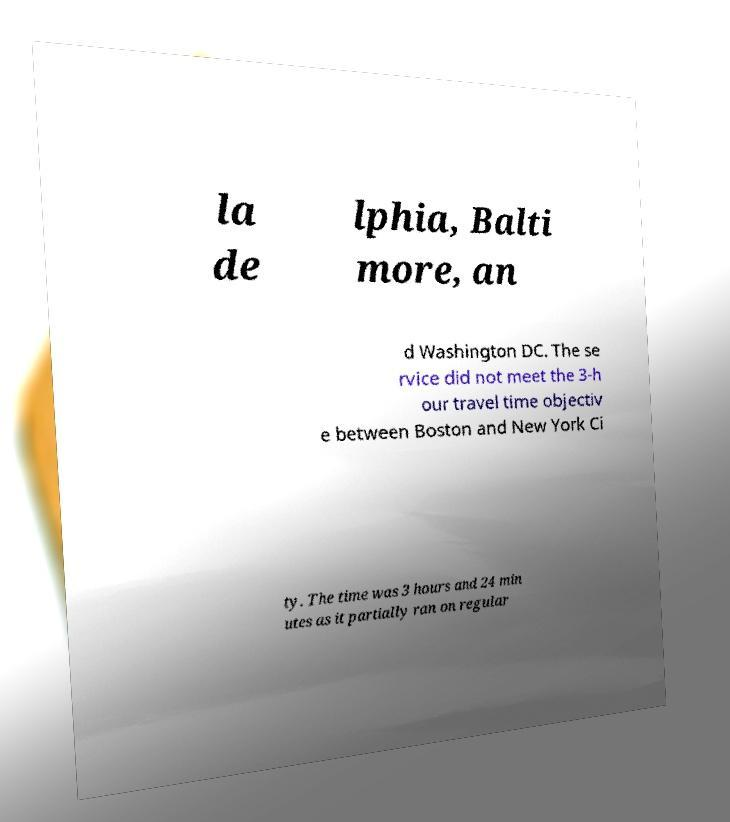Please read and relay the text visible in this image. What does it say? la de lphia, Balti more, an d Washington DC. The se rvice did not meet the 3-h our travel time objectiv e between Boston and New York Ci ty. The time was 3 hours and 24 min utes as it partially ran on regular 